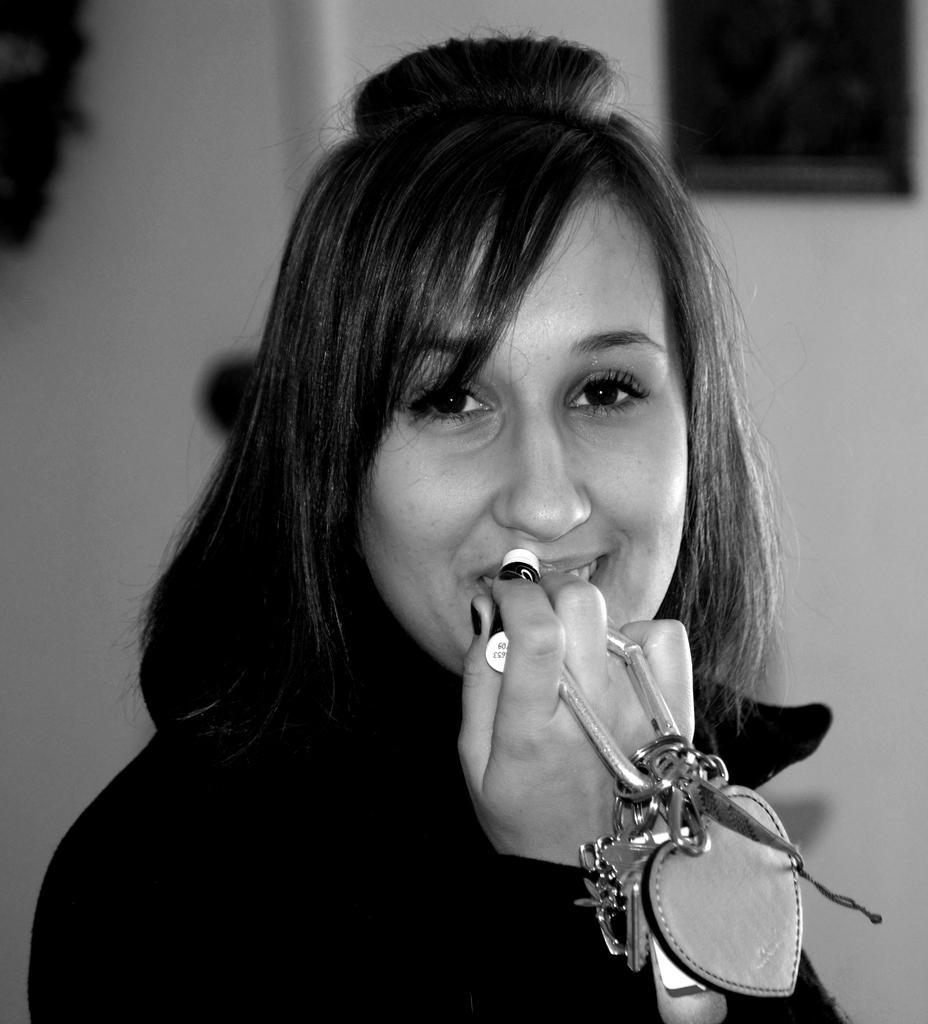In one or two sentences, can you explain what this image depicts? In this image we can see the person standing and holding key chain and an object. And at the back we can see the blur background. 